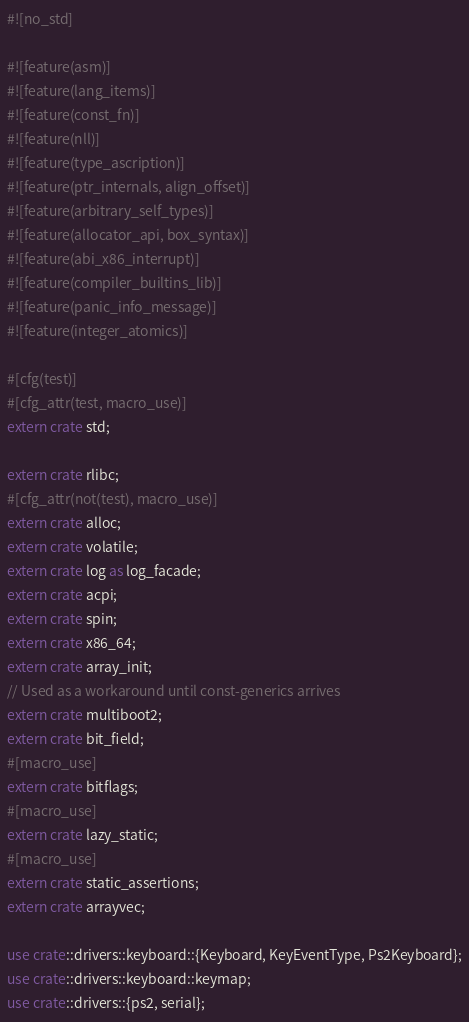Convert code to text. <code><loc_0><loc_0><loc_500><loc_500><_Rust_>#![no_std]

#![feature(asm)]
#![feature(lang_items)]
#![feature(const_fn)]
#![feature(nll)]
#![feature(type_ascription)]
#![feature(ptr_internals, align_offset)]
#![feature(arbitrary_self_types)]
#![feature(allocator_api, box_syntax)]
#![feature(abi_x86_interrupt)]
#![feature(compiler_builtins_lib)]
#![feature(panic_info_message)]
#![feature(integer_atomics)]

#[cfg(test)]
#[cfg_attr(test, macro_use)]
extern crate std;

extern crate rlibc;
#[cfg_attr(not(test), macro_use)]
extern crate alloc;
extern crate volatile;
extern crate log as log_facade;
extern crate acpi;
extern crate spin;
extern crate x86_64;
extern crate array_init;
// Used as a workaround until const-generics arrives
extern crate multiboot2;
extern crate bit_field;
#[macro_use]
extern crate bitflags;
#[macro_use]
extern crate lazy_static;
#[macro_use]
extern crate static_assertions;
extern crate arrayvec;

use crate::drivers::keyboard::{Keyboard, KeyEventType, Ps2Keyboard};
use crate::drivers::keyboard::keymap;
use crate::drivers::{ps2, serial};</code> 